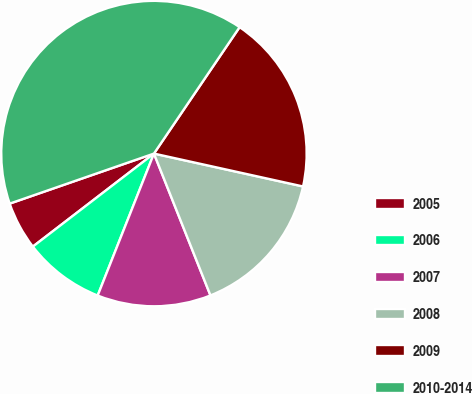Convert chart. <chart><loc_0><loc_0><loc_500><loc_500><pie_chart><fcel>2005<fcel>2006<fcel>2007<fcel>2008<fcel>2009<fcel>2010-2014<nl><fcel>5.11%<fcel>8.57%<fcel>12.04%<fcel>15.51%<fcel>18.98%<fcel>39.79%<nl></chart> 